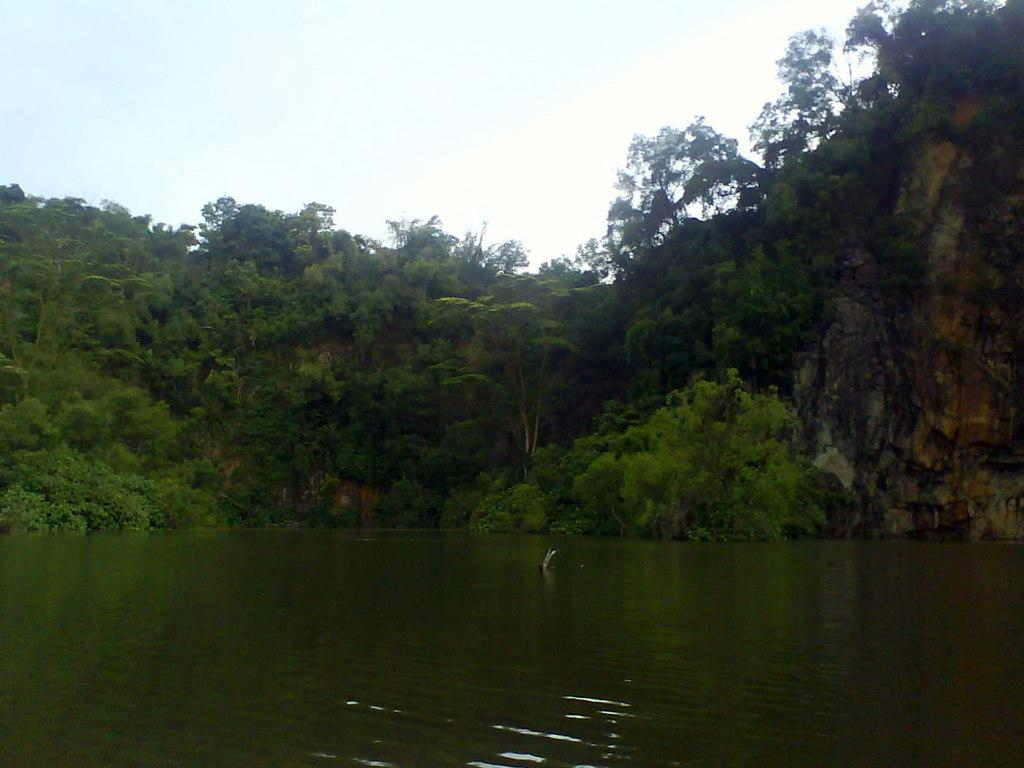What can be seen in the background of the image? The sky is visible in the background of the image. What type of vegetation is present in the image? There are trees and plants in the image. What is the body of water visible in the image? There is water visible in the image. Where is the hill located in the image? The hill is on the right side of the image. What type of story is being told in the hall in the image? There is no hall or story present in the image; it features a sky, trees, plants, water, and a hill. How many times is the roll of fabric used in the image? There is no roll of fabric present in the image. 